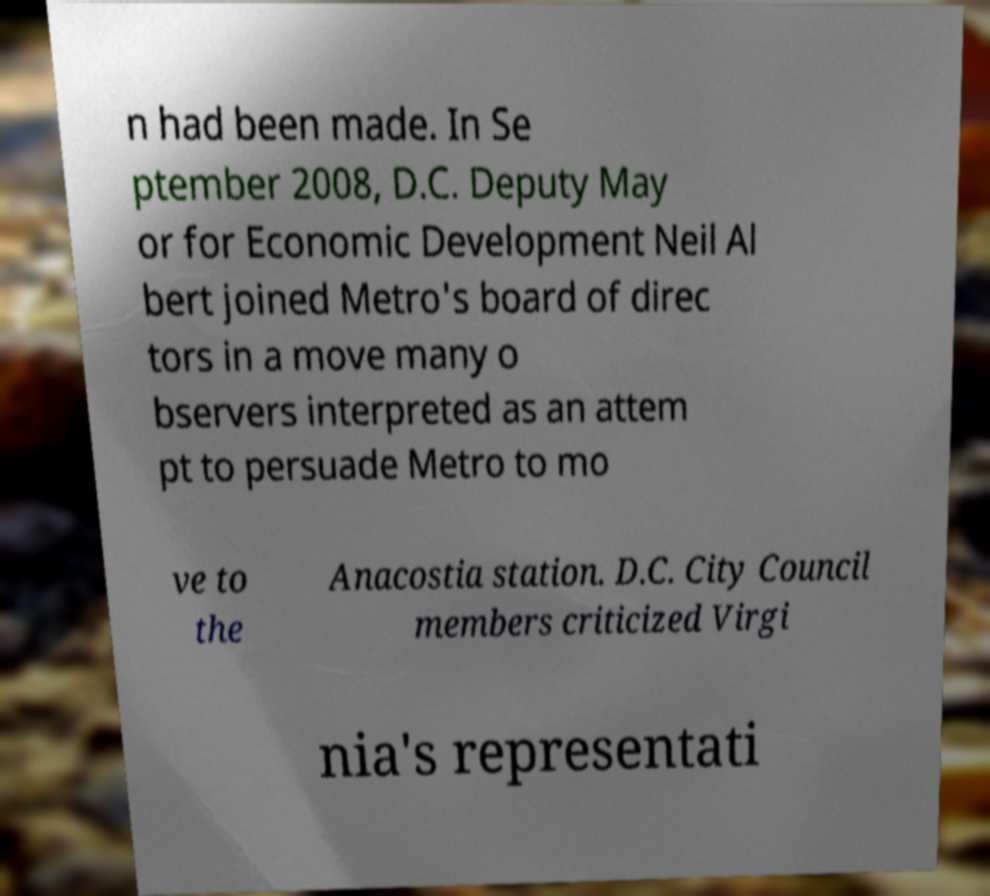For documentation purposes, I need the text within this image transcribed. Could you provide that? n had been made. In Se ptember 2008, D.C. Deputy May or for Economic Development Neil Al bert joined Metro's board of direc tors in a move many o bservers interpreted as an attem pt to persuade Metro to mo ve to the Anacostia station. D.C. City Council members criticized Virgi nia's representati 